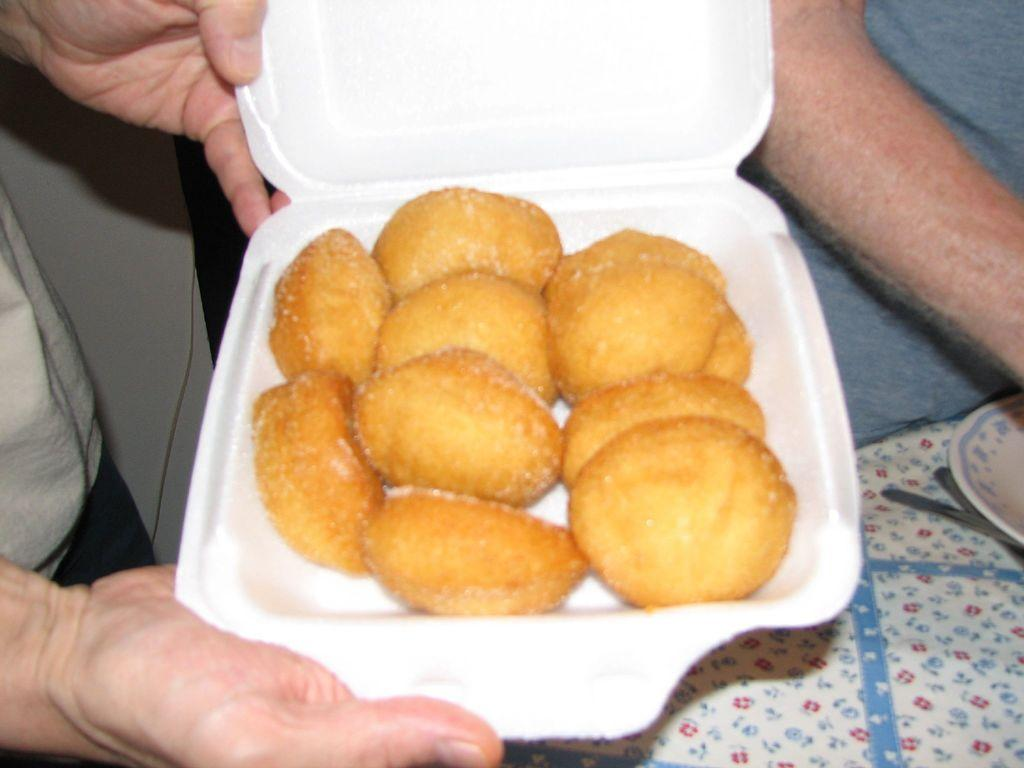What is inside the white box in the image? There is food inside the white box in the image. Who is holding the white box? A person is holding the white box. Can you describe the person on the right side of the image? There is a person on the right side of the image, but no specific details about their appearance are provided. What is on the table on the right side of the image? There is a plate on the right side of the image, which is on the table. What else can be seen on the right side of the image? There are other unspecified things on the right side of the image. How many beggars are visible in the image? There is no mention of beggars in the image, so it is impossible to determine their presence or number. What type of crackers are on the plate in the image? There is no mention of crackers in the image, so it is impossible to determine their presence or type. 